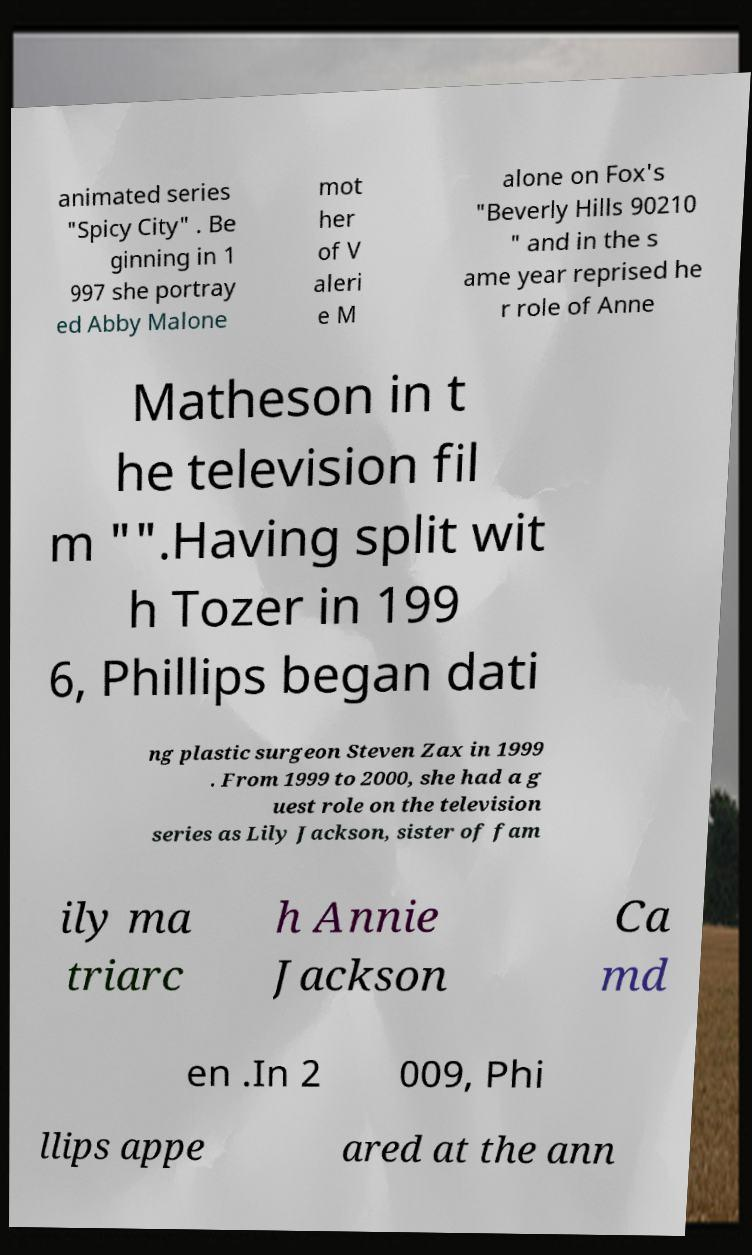Could you assist in decoding the text presented in this image and type it out clearly? animated series "Spicy City" . Be ginning in 1 997 she portray ed Abby Malone mot her of V aleri e M alone on Fox's "Beverly Hills 90210 " and in the s ame year reprised he r role of Anne Matheson in t he television fil m "".Having split wit h Tozer in 199 6, Phillips began dati ng plastic surgeon Steven Zax in 1999 . From 1999 to 2000, she had a g uest role on the television series as Lily Jackson, sister of fam ily ma triarc h Annie Jackson Ca md en .In 2 009, Phi llips appe ared at the ann 